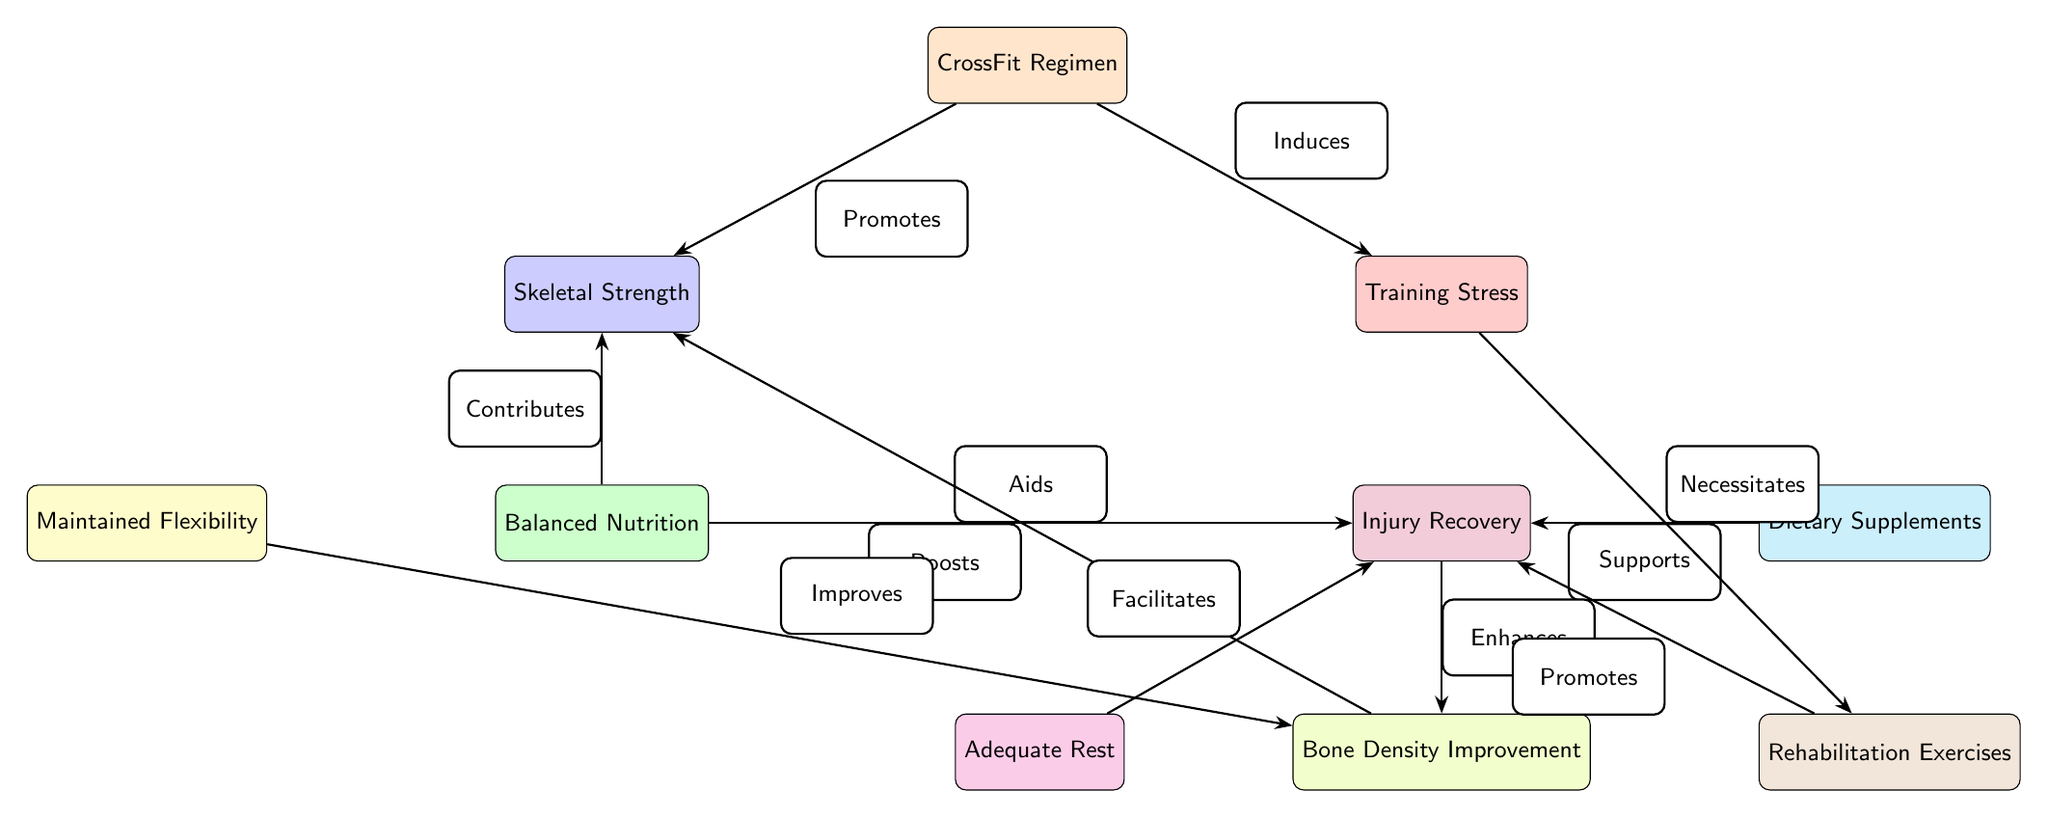What's the total number of nodes in the diagram? The diagram includes nine distinct nodes: CrossFit Regimen, Skeletal Strength, Training Stress, Balanced Nutrition, Injury Recovery, Maintained Flexibility, Dietary Supplements, Adequate Rest, Rehabilitation Exercises, and Bone Density Improvement. Therefore, the total count is nine.
Answer: 9 What promotes skeletal strength in this diagram? The diagram indicates that skeletal strength is promoted by the CrossFit regimen, as noted by the edge labeled "Promotes" connecting these two nodes.
Answer: CrossFit Regimen Which node aids in injury recovery? Balanced Nutrition is specified as aiding in injury recovery, represented by the edge labeled "Aids" that connects Balanced Nutrition and Injury Recovery.
Answer: Balanced Nutrition How many edges connect to the injury recovery node? The injury recovery node has five edges leading to it from other nodes: Balanced Nutrition, Dietary Supplements, Adequate Rest, Rehabilitation Exercises, and Bone Density Improvement. Thus, the total number of edges is five.
Answer: 5 What is the relationship between training stress and rehabilitation exercises? Training stress necessitates rehabilitation exercises, as highlighted by the edge labeled "Necessitates" connecting these two nodes in the diagram.
Answer: Necessitates How does adequate rest contribute to the injury recovery process? Adequate rest facilitates injury recovery, which is illustrated by the edge connecting Adequate Rest and Injury Recovery, labeled "Facilitates." Therefore, adequate rest has a positive role in the recovery process.
Answer: Facilitates What supports injury recovery according to the diagram? The diagram indicates that dietary supplements support injury recovery, as indicated by the edge labeled "Supports" connecting these two nodes.
Answer: Dietary Supplements What improves bone density? Both maintained flexibility and balanced nutrition are indicated to improve bone density, each contributing from their respective nodes. The connections are shown by edges coming from these nodes to Bone Density Improvement.
Answer: Maintained Flexibility, Balanced Nutrition What enhances bone density? The recovery node enhances bone density, as depicted by the edge labeled "Enhances" that connects Injury Recovery and Bone Density Improvement in the diagram.
Answer: Injury Recovery 